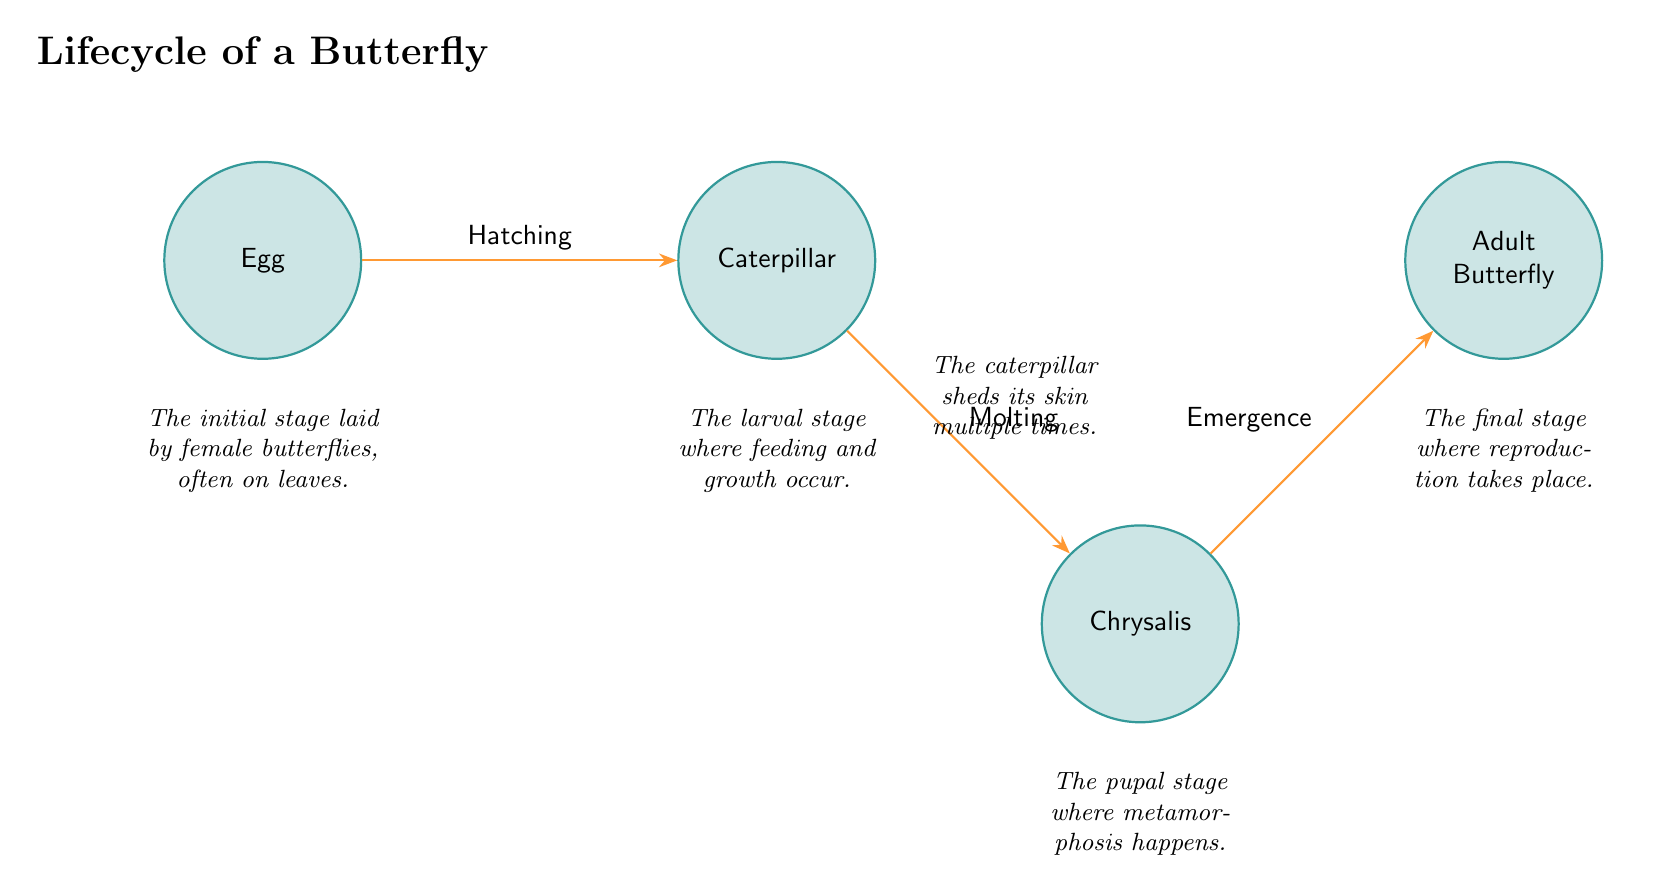What is the first stage in the lifecycle of a butterfly? The diagram clearly labels "Egg" as the first stage. This is seen at the leftmost position in the flow of lifecycle stages.
Answer: Egg What happens after the larval stage? The diagram displays an arrow leading from "Caterpillar" to "Chrysalis," indicating that the next stage after the larval stage is the pupal stage.
Answer: Chrysalis How many stages are represented in the diagram? By counting the distinct stages labeled in the diagram—Egg, Caterpillar, Chrysalis, and Adult Butterfly—there are a total of four stages.
Answer: 4 What is the process that occurs during the transition from Caterpillar to Chrysalis? The transition is labeled "Molting," which is indicated on the diagram with an arrow from "Caterpillar" to "Chrysalis."
Answer: Molting What does the adult butterfly stage signify? The diagram notes that the final stage of an adult butterfly is where reproduction occurs, as described under the "Adult Butterfly" label.
Answer: Reproduction What is the purpose of the egg stage in the lifecycle? Under "Egg," the description states that this stage is the initial one laid by female butterflies, often on leaves, highlighting its reproductive purpose.
Answer: Laying What occurs in the pupal stage? The description associated with "Chrysalis" states that this is the stage where metamorphosis happens, indicating a significant transformation process.
Answer: Metamorphosis What is the transition called from Egg to Caterpillar? The arrow linking "Egg" and "Caterpillar" is labeled "Hatching," showing the process to transition into the larval form.
Answer: Hatching How do butterflies undergo growth during their lifecycle? The "Caterpillar" stage has a description indicating the stage where feeding and growth occur, highlighting the importance of this phase for the butterfly's development.
Answer: Feeding and growth 